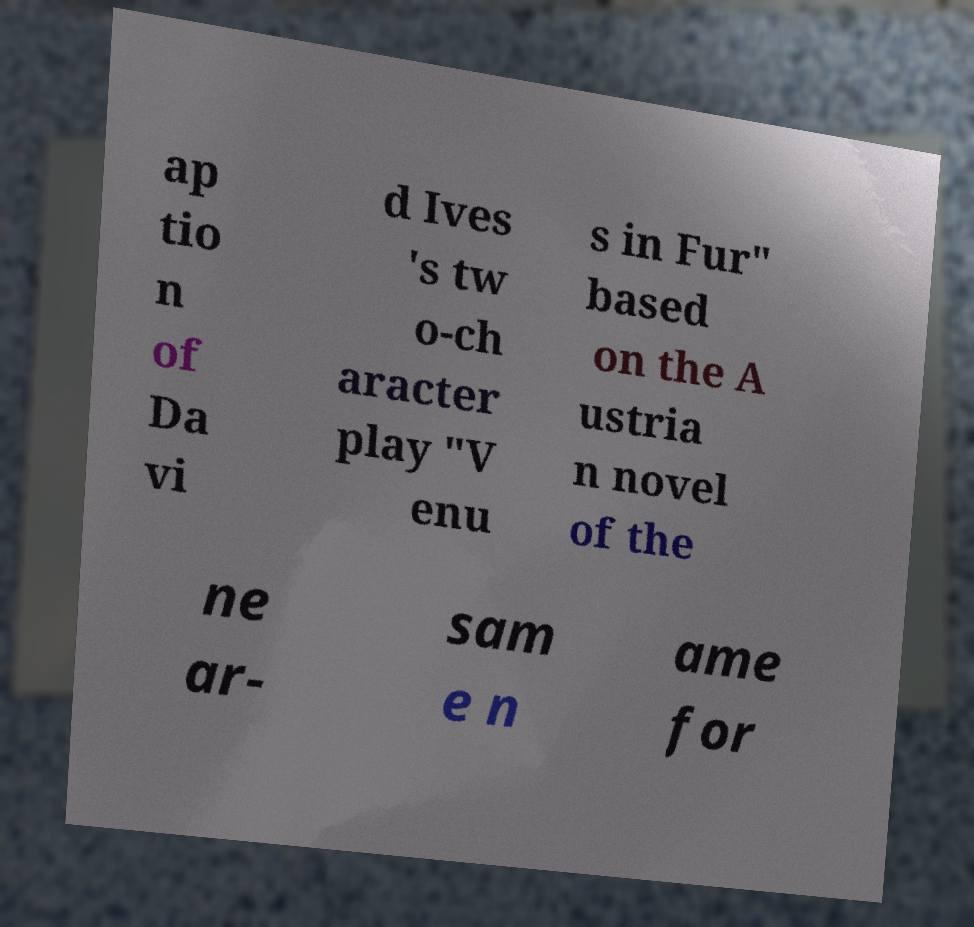Could you extract and type out the text from this image? ap tio n of Da vi d Ives 's tw o-ch aracter play "V enu s in Fur" based on the A ustria n novel of the ne ar- sam e n ame for 